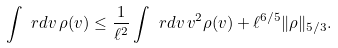<formula> <loc_0><loc_0><loc_500><loc_500>\int \ r d v \, \rho ( v ) \leq \frac { 1 } { \ell ^ { 2 } } \int \ r d v \, v ^ { 2 } \rho ( v ) + \ell ^ { 6 / 5 } \| \rho \| _ { 5 / 3 } .</formula> 